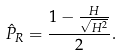Convert formula to latex. <formula><loc_0><loc_0><loc_500><loc_500>\hat { P } _ { R } = \frac { 1 - \frac { H } { \sqrt { H ^ { 2 } } } } { 2 } .</formula> 